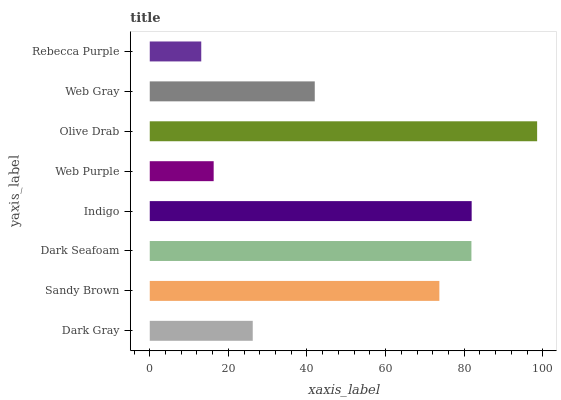Is Rebecca Purple the minimum?
Answer yes or no. Yes. Is Olive Drab the maximum?
Answer yes or no. Yes. Is Sandy Brown the minimum?
Answer yes or no. No. Is Sandy Brown the maximum?
Answer yes or no. No. Is Sandy Brown greater than Dark Gray?
Answer yes or no. Yes. Is Dark Gray less than Sandy Brown?
Answer yes or no. Yes. Is Dark Gray greater than Sandy Brown?
Answer yes or no. No. Is Sandy Brown less than Dark Gray?
Answer yes or no. No. Is Sandy Brown the high median?
Answer yes or no. Yes. Is Web Gray the low median?
Answer yes or no. Yes. Is Dark Gray the high median?
Answer yes or no. No. Is Indigo the low median?
Answer yes or no. No. 